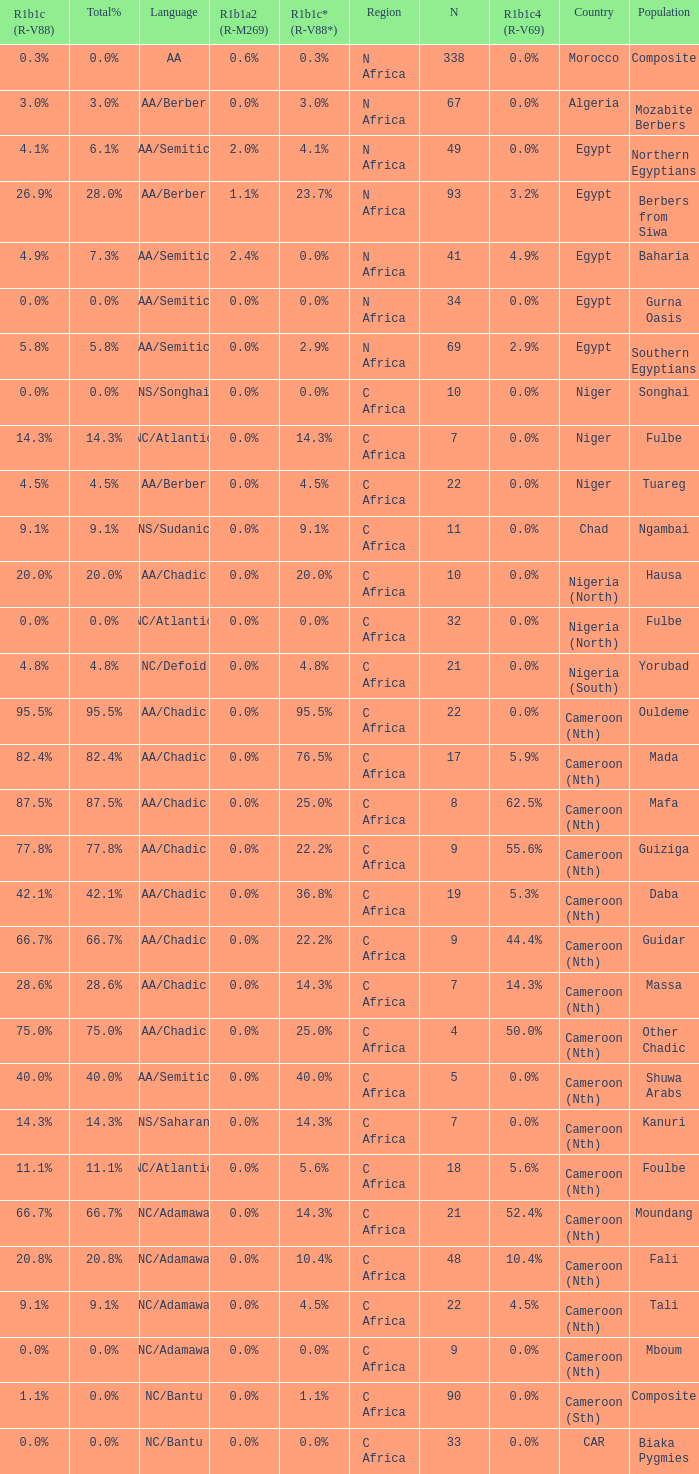Parse the full table. {'header': ['R1b1c (R-V88)', 'Total%', 'Language', 'R1b1a2 (R-M269)', 'R1b1c* (R-V88*)', 'Region', 'N', 'R1b1c4 (R-V69)', 'Country', 'Population'], 'rows': [['0.3%', '0.0%', 'AA', '0.6%', '0.3%', 'N Africa', '338', '0.0%', 'Morocco', 'Composite'], ['3.0%', '3.0%', 'AA/Berber', '0.0%', '3.0%', 'N Africa', '67', '0.0%', 'Algeria', 'Mozabite Berbers'], ['4.1%', '6.1%', 'AA/Semitic', '2.0%', '4.1%', 'N Africa', '49', '0.0%', 'Egypt', 'Northern Egyptians'], ['26.9%', '28.0%', 'AA/Berber', '1.1%', '23.7%', 'N Africa', '93', '3.2%', 'Egypt', 'Berbers from Siwa'], ['4.9%', '7.3%', 'AA/Semitic', '2.4%', '0.0%', 'N Africa', '41', '4.9%', 'Egypt', 'Baharia'], ['0.0%', '0.0%', 'AA/Semitic', '0.0%', '0.0%', 'N Africa', '34', '0.0%', 'Egypt', 'Gurna Oasis'], ['5.8%', '5.8%', 'AA/Semitic', '0.0%', '2.9%', 'N Africa', '69', '2.9%', 'Egypt', 'Southern Egyptians'], ['0.0%', '0.0%', 'NS/Songhai', '0.0%', '0.0%', 'C Africa', '10', '0.0%', 'Niger', 'Songhai'], ['14.3%', '14.3%', 'NC/Atlantic', '0.0%', '14.3%', 'C Africa', '7', '0.0%', 'Niger', 'Fulbe'], ['4.5%', '4.5%', 'AA/Berber', '0.0%', '4.5%', 'C Africa', '22', '0.0%', 'Niger', 'Tuareg'], ['9.1%', '9.1%', 'NS/Sudanic', '0.0%', '9.1%', 'C Africa', '11', '0.0%', 'Chad', 'Ngambai'], ['20.0%', '20.0%', 'AA/Chadic', '0.0%', '20.0%', 'C Africa', '10', '0.0%', 'Nigeria (North)', 'Hausa'], ['0.0%', '0.0%', 'NC/Atlantic', '0.0%', '0.0%', 'C Africa', '32', '0.0%', 'Nigeria (North)', 'Fulbe'], ['4.8%', '4.8%', 'NC/Defoid', '0.0%', '4.8%', 'C Africa', '21', '0.0%', 'Nigeria (South)', 'Yorubad'], ['95.5%', '95.5%', 'AA/Chadic', '0.0%', '95.5%', 'C Africa', '22', '0.0%', 'Cameroon (Nth)', 'Ouldeme'], ['82.4%', '82.4%', 'AA/Chadic', '0.0%', '76.5%', 'C Africa', '17', '5.9%', 'Cameroon (Nth)', 'Mada'], ['87.5%', '87.5%', 'AA/Chadic', '0.0%', '25.0%', 'C Africa', '8', '62.5%', 'Cameroon (Nth)', 'Mafa'], ['77.8%', '77.8%', 'AA/Chadic', '0.0%', '22.2%', 'C Africa', '9', '55.6%', 'Cameroon (Nth)', 'Guiziga'], ['42.1%', '42.1%', 'AA/Chadic', '0.0%', '36.8%', 'C Africa', '19', '5.3%', 'Cameroon (Nth)', 'Daba'], ['66.7%', '66.7%', 'AA/Chadic', '0.0%', '22.2%', 'C Africa', '9', '44.4%', 'Cameroon (Nth)', 'Guidar'], ['28.6%', '28.6%', 'AA/Chadic', '0.0%', '14.3%', 'C Africa', '7', '14.3%', 'Cameroon (Nth)', 'Massa'], ['75.0%', '75.0%', 'AA/Chadic', '0.0%', '25.0%', 'C Africa', '4', '50.0%', 'Cameroon (Nth)', 'Other Chadic'], ['40.0%', '40.0%', 'AA/Semitic', '0.0%', '40.0%', 'C Africa', '5', '0.0%', 'Cameroon (Nth)', 'Shuwa Arabs'], ['14.3%', '14.3%', 'NS/Saharan', '0.0%', '14.3%', 'C Africa', '7', '0.0%', 'Cameroon (Nth)', 'Kanuri'], ['11.1%', '11.1%', 'NC/Atlantic', '0.0%', '5.6%', 'C Africa', '18', '5.6%', 'Cameroon (Nth)', 'Foulbe'], ['66.7%', '66.7%', 'NC/Adamawa', '0.0%', '14.3%', 'C Africa', '21', '52.4%', 'Cameroon (Nth)', 'Moundang'], ['20.8%', '20.8%', 'NC/Adamawa', '0.0%', '10.4%', 'C Africa', '48', '10.4%', 'Cameroon (Nth)', 'Fali'], ['9.1%', '9.1%', 'NC/Adamawa', '0.0%', '4.5%', 'C Africa', '22', '4.5%', 'Cameroon (Nth)', 'Tali'], ['0.0%', '0.0%', 'NC/Adamawa', '0.0%', '0.0%', 'C Africa', '9', '0.0%', 'Cameroon (Nth)', 'Mboum'], ['1.1%', '0.0%', 'NC/Bantu', '0.0%', '1.1%', 'C Africa', '90', '0.0%', 'Cameroon (Sth)', 'Composite'], ['0.0%', '0.0%', 'NC/Bantu', '0.0%', '0.0%', 'C Africa', '33', '0.0%', 'CAR', 'Biaka Pygmies']]} What is the largest n value for 55.6% r1b1c4 (r-v69)? 9.0. 